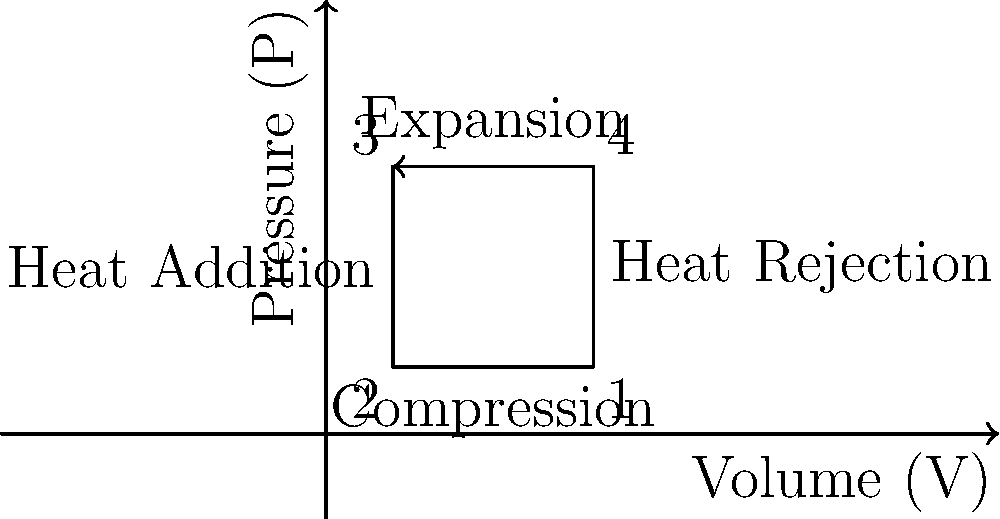As a food influencer exploring innovative culinary techniques, you've come across molecular gastronomy that uses liquid nitrogen for flash freezing. This process involves a refrigeration cycle. Based on the pressure-volume (P-V) diagram shown, which stage of the cycle represents the compression of the refrigerant? To answer this question, let's analyze the P-V diagram of the refrigeration cycle:

1. The diagram shows a clockwise cycle with four distinct stages, labeled 1 to 4.

2. In a refrigeration cycle, the stages are typically:
   - Compression
   - Heat rejection (condensation)
   - Expansion
   - Heat absorption (evaporation)

3. We're looking for the compression stage, which is characterized by:
   - Increasing pressure
   - Decreasing volume

4. Examining the diagram:
   - The process from point 1 to 2 shows increasing pressure and decreasing volume.
   - This is the only stage that exhibits these characteristics.

5. The label "Compression" is also visible along this line, confirming our analysis.

Therefore, the stage from point 1 to point 2, which shows increasing pressure and decreasing volume, represents the compression of the refrigerant in the cycle.
Answer: 1 to 2 